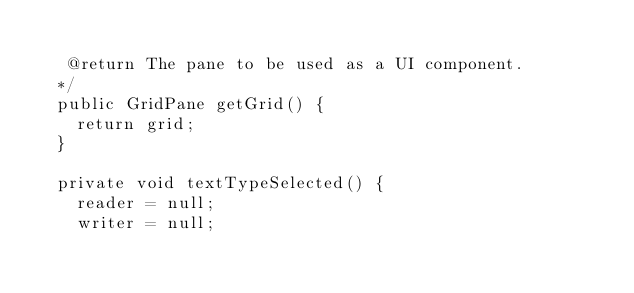<code> <loc_0><loc_0><loc_500><loc_500><_Java_>  
   @return The pane to be used as a UI component.
  */
  public GridPane getGrid() {
    return grid;
  }

  private void textTypeSelected() {
    reader = null;
    writer = null;</code> 